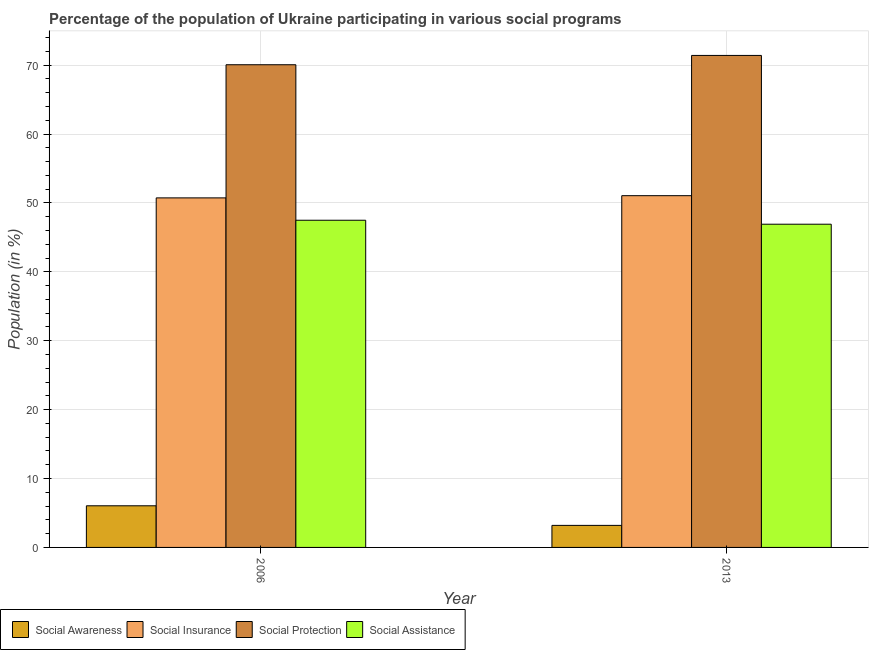Are the number of bars per tick equal to the number of legend labels?
Offer a terse response. Yes. Are the number of bars on each tick of the X-axis equal?
Offer a very short reply. Yes. What is the label of the 2nd group of bars from the left?
Your response must be concise. 2013. What is the participation of population in social awareness programs in 2013?
Ensure brevity in your answer.  3.2. Across all years, what is the maximum participation of population in social insurance programs?
Make the answer very short. 51.06. Across all years, what is the minimum participation of population in social awareness programs?
Make the answer very short. 3.2. In which year was the participation of population in social awareness programs minimum?
Your response must be concise. 2013. What is the total participation of population in social awareness programs in the graph?
Offer a terse response. 9.24. What is the difference between the participation of population in social assistance programs in 2006 and that in 2013?
Your response must be concise. 0.58. What is the difference between the participation of population in social protection programs in 2013 and the participation of population in social awareness programs in 2006?
Offer a terse response. 1.35. What is the average participation of population in social assistance programs per year?
Offer a terse response. 47.21. What is the ratio of the participation of population in social awareness programs in 2006 to that in 2013?
Keep it short and to the point. 1.89. Is the participation of population in social assistance programs in 2006 less than that in 2013?
Ensure brevity in your answer.  No. What does the 4th bar from the left in 2013 represents?
Offer a very short reply. Social Assistance. What does the 3rd bar from the right in 2006 represents?
Offer a terse response. Social Insurance. Is it the case that in every year, the sum of the participation of population in social awareness programs and participation of population in social insurance programs is greater than the participation of population in social protection programs?
Provide a succinct answer. No. How many bars are there?
Your response must be concise. 8. Are all the bars in the graph horizontal?
Ensure brevity in your answer.  No. What is the difference between two consecutive major ticks on the Y-axis?
Give a very brief answer. 10. Does the graph contain grids?
Provide a short and direct response. Yes. What is the title of the graph?
Your response must be concise. Percentage of the population of Ukraine participating in various social programs . What is the label or title of the Y-axis?
Your response must be concise. Population (in %). What is the Population (in %) of Social Awareness in 2006?
Offer a very short reply. 6.04. What is the Population (in %) in Social Insurance in 2006?
Your answer should be compact. 50.74. What is the Population (in %) in Social Protection in 2006?
Ensure brevity in your answer.  70.07. What is the Population (in %) in Social Assistance in 2006?
Offer a terse response. 47.5. What is the Population (in %) of Social Awareness in 2013?
Offer a very short reply. 3.2. What is the Population (in %) in Social Insurance in 2013?
Provide a short and direct response. 51.06. What is the Population (in %) of Social Protection in 2013?
Provide a succinct answer. 71.42. What is the Population (in %) in Social Assistance in 2013?
Provide a short and direct response. 46.92. Across all years, what is the maximum Population (in %) of Social Awareness?
Give a very brief answer. 6.04. Across all years, what is the maximum Population (in %) of Social Insurance?
Offer a terse response. 51.06. Across all years, what is the maximum Population (in %) in Social Protection?
Offer a terse response. 71.42. Across all years, what is the maximum Population (in %) in Social Assistance?
Give a very brief answer. 47.5. Across all years, what is the minimum Population (in %) in Social Awareness?
Offer a terse response. 3.2. Across all years, what is the minimum Population (in %) in Social Insurance?
Make the answer very short. 50.74. Across all years, what is the minimum Population (in %) of Social Protection?
Make the answer very short. 70.07. Across all years, what is the minimum Population (in %) in Social Assistance?
Your response must be concise. 46.92. What is the total Population (in %) of Social Awareness in the graph?
Give a very brief answer. 9.24. What is the total Population (in %) in Social Insurance in the graph?
Keep it short and to the point. 101.8. What is the total Population (in %) of Social Protection in the graph?
Offer a very short reply. 141.49. What is the total Population (in %) of Social Assistance in the graph?
Provide a succinct answer. 94.41. What is the difference between the Population (in %) in Social Awareness in 2006 and that in 2013?
Give a very brief answer. 2.84. What is the difference between the Population (in %) in Social Insurance in 2006 and that in 2013?
Ensure brevity in your answer.  -0.32. What is the difference between the Population (in %) in Social Protection in 2006 and that in 2013?
Offer a very short reply. -1.35. What is the difference between the Population (in %) in Social Assistance in 2006 and that in 2013?
Ensure brevity in your answer.  0.58. What is the difference between the Population (in %) in Social Awareness in 2006 and the Population (in %) in Social Insurance in 2013?
Give a very brief answer. -45.01. What is the difference between the Population (in %) in Social Awareness in 2006 and the Population (in %) in Social Protection in 2013?
Your response must be concise. -65.38. What is the difference between the Population (in %) of Social Awareness in 2006 and the Population (in %) of Social Assistance in 2013?
Offer a very short reply. -40.87. What is the difference between the Population (in %) of Social Insurance in 2006 and the Population (in %) of Social Protection in 2013?
Your answer should be compact. -20.68. What is the difference between the Population (in %) of Social Insurance in 2006 and the Population (in %) of Social Assistance in 2013?
Offer a terse response. 3.82. What is the difference between the Population (in %) of Social Protection in 2006 and the Population (in %) of Social Assistance in 2013?
Your answer should be very brief. 23.15. What is the average Population (in %) in Social Awareness per year?
Ensure brevity in your answer.  4.62. What is the average Population (in %) of Social Insurance per year?
Make the answer very short. 50.9. What is the average Population (in %) in Social Protection per year?
Your response must be concise. 70.74. What is the average Population (in %) of Social Assistance per year?
Your response must be concise. 47.21. In the year 2006, what is the difference between the Population (in %) of Social Awareness and Population (in %) of Social Insurance?
Keep it short and to the point. -44.7. In the year 2006, what is the difference between the Population (in %) in Social Awareness and Population (in %) in Social Protection?
Provide a succinct answer. -64.02. In the year 2006, what is the difference between the Population (in %) in Social Awareness and Population (in %) in Social Assistance?
Give a very brief answer. -41.45. In the year 2006, what is the difference between the Population (in %) in Social Insurance and Population (in %) in Social Protection?
Give a very brief answer. -19.33. In the year 2006, what is the difference between the Population (in %) in Social Insurance and Population (in %) in Social Assistance?
Your answer should be compact. 3.24. In the year 2006, what is the difference between the Population (in %) of Social Protection and Population (in %) of Social Assistance?
Offer a terse response. 22.57. In the year 2013, what is the difference between the Population (in %) of Social Awareness and Population (in %) of Social Insurance?
Your answer should be compact. -47.86. In the year 2013, what is the difference between the Population (in %) in Social Awareness and Population (in %) in Social Protection?
Your answer should be compact. -68.22. In the year 2013, what is the difference between the Population (in %) in Social Awareness and Population (in %) in Social Assistance?
Keep it short and to the point. -43.72. In the year 2013, what is the difference between the Population (in %) of Social Insurance and Population (in %) of Social Protection?
Give a very brief answer. -20.36. In the year 2013, what is the difference between the Population (in %) in Social Insurance and Population (in %) in Social Assistance?
Offer a very short reply. 4.14. In the year 2013, what is the difference between the Population (in %) in Social Protection and Population (in %) in Social Assistance?
Keep it short and to the point. 24.5. What is the ratio of the Population (in %) of Social Awareness in 2006 to that in 2013?
Your response must be concise. 1.89. What is the ratio of the Population (in %) of Social Protection in 2006 to that in 2013?
Give a very brief answer. 0.98. What is the ratio of the Population (in %) of Social Assistance in 2006 to that in 2013?
Ensure brevity in your answer.  1.01. What is the difference between the highest and the second highest Population (in %) in Social Awareness?
Your answer should be very brief. 2.84. What is the difference between the highest and the second highest Population (in %) of Social Insurance?
Your response must be concise. 0.32. What is the difference between the highest and the second highest Population (in %) in Social Protection?
Keep it short and to the point. 1.35. What is the difference between the highest and the second highest Population (in %) in Social Assistance?
Offer a terse response. 0.58. What is the difference between the highest and the lowest Population (in %) in Social Awareness?
Offer a very short reply. 2.84. What is the difference between the highest and the lowest Population (in %) of Social Insurance?
Give a very brief answer. 0.32. What is the difference between the highest and the lowest Population (in %) of Social Protection?
Your response must be concise. 1.35. What is the difference between the highest and the lowest Population (in %) in Social Assistance?
Your response must be concise. 0.58. 